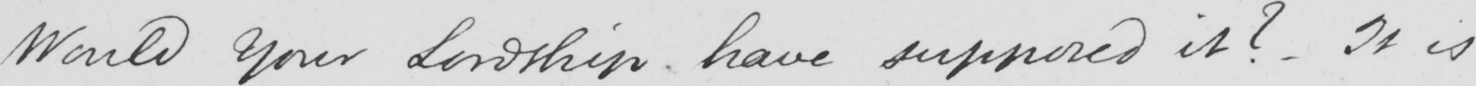What text is written in this handwritten line? Would Your Lordship have supposed it ?  - It is 